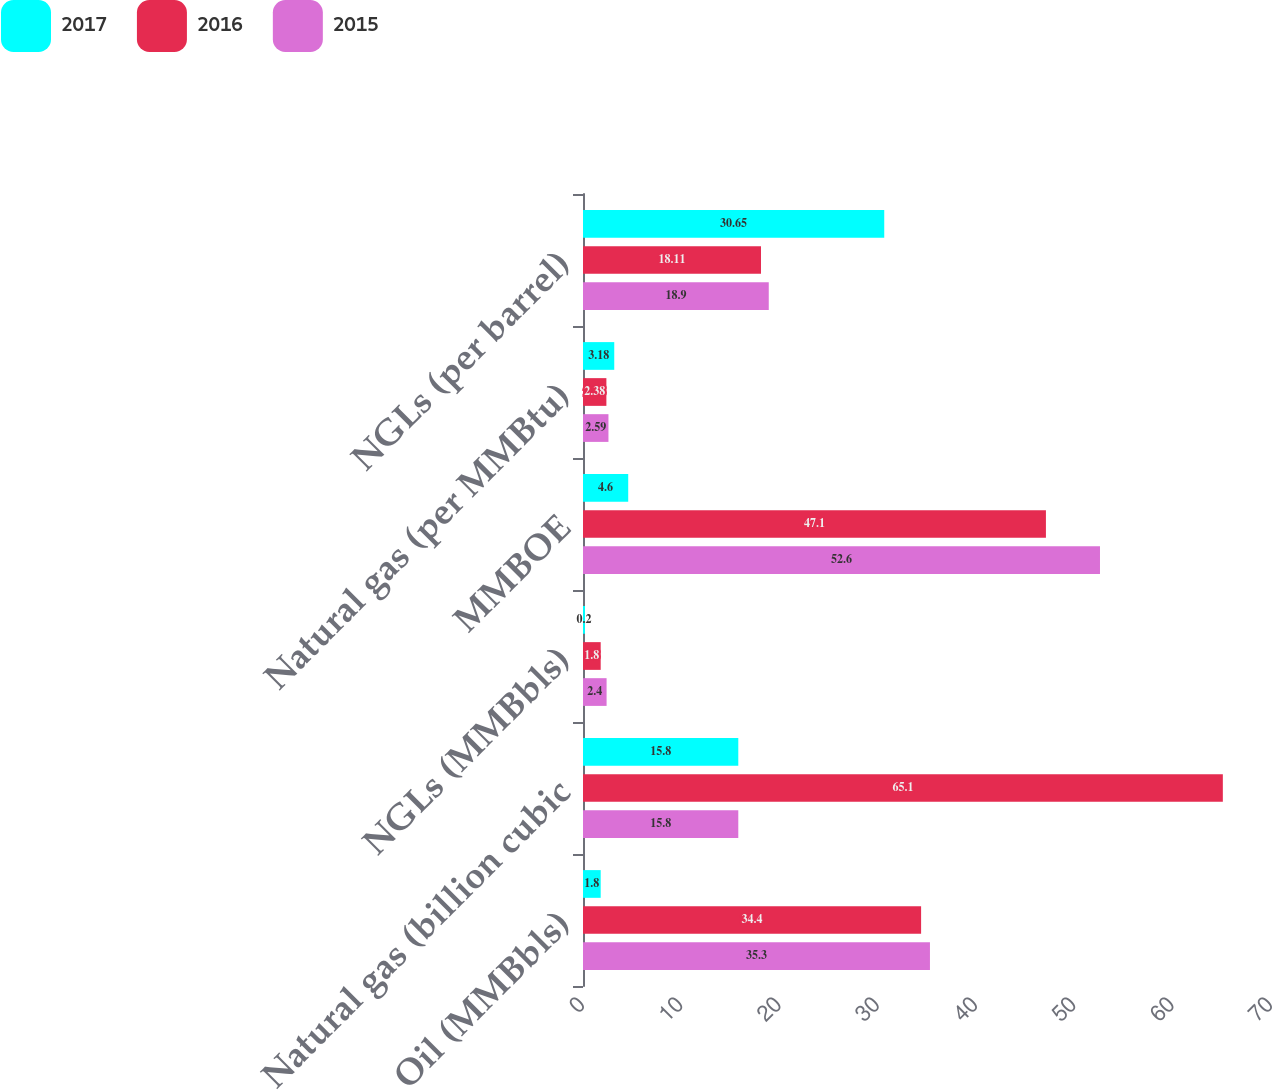<chart> <loc_0><loc_0><loc_500><loc_500><stacked_bar_chart><ecel><fcel>Oil (MMBbls)<fcel>Natural gas (billion cubic<fcel>NGLs (MMBbls)<fcel>MMBOE<fcel>Natural gas (per MMBtu)<fcel>NGLs (per barrel)<nl><fcel>2017<fcel>1.8<fcel>15.8<fcel>0.2<fcel>4.6<fcel>3.18<fcel>30.65<nl><fcel>2016<fcel>34.4<fcel>65.1<fcel>1.8<fcel>47.1<fcel>2.38<fcel>18.11<nl><fcel>2015<fcel>35.3<fcel>15.8<fcel>2.4<fcel>52.6<fcel>2.59<fcel>18.9<nl></chart> 